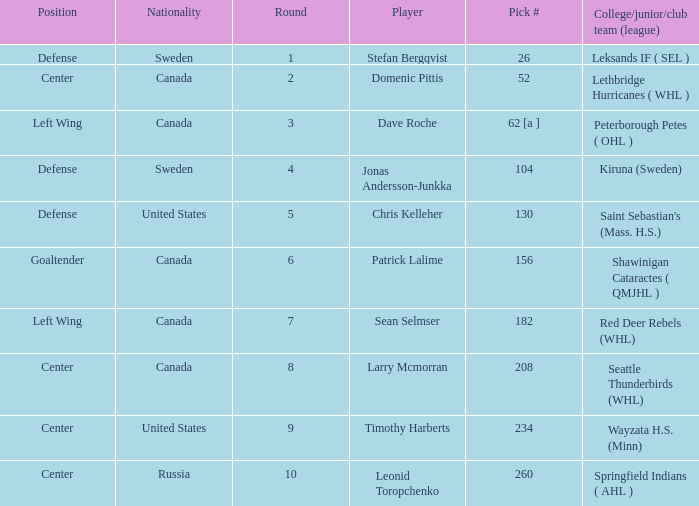What is the nationality of the player whose college/junior/club team (league) is Seattle Thunderbirds (WHL)? Canada. 